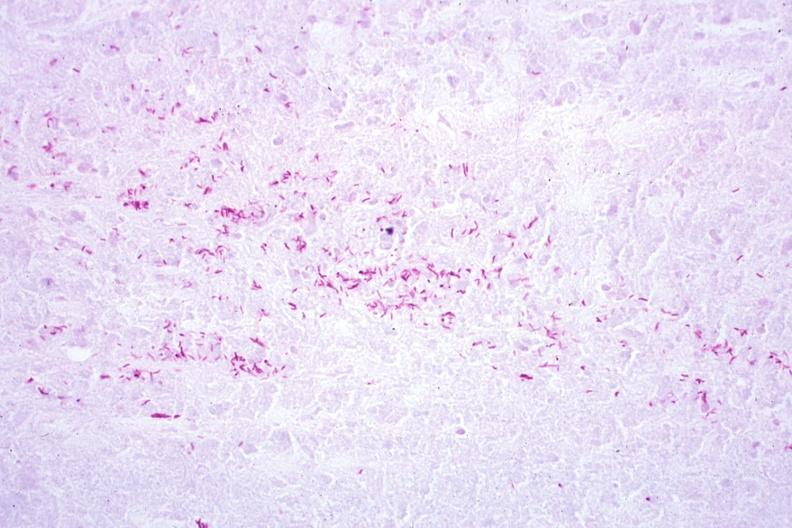what does this image show?
Answer the question using a single word or phrase. Acid fast stain a zillion organisms 